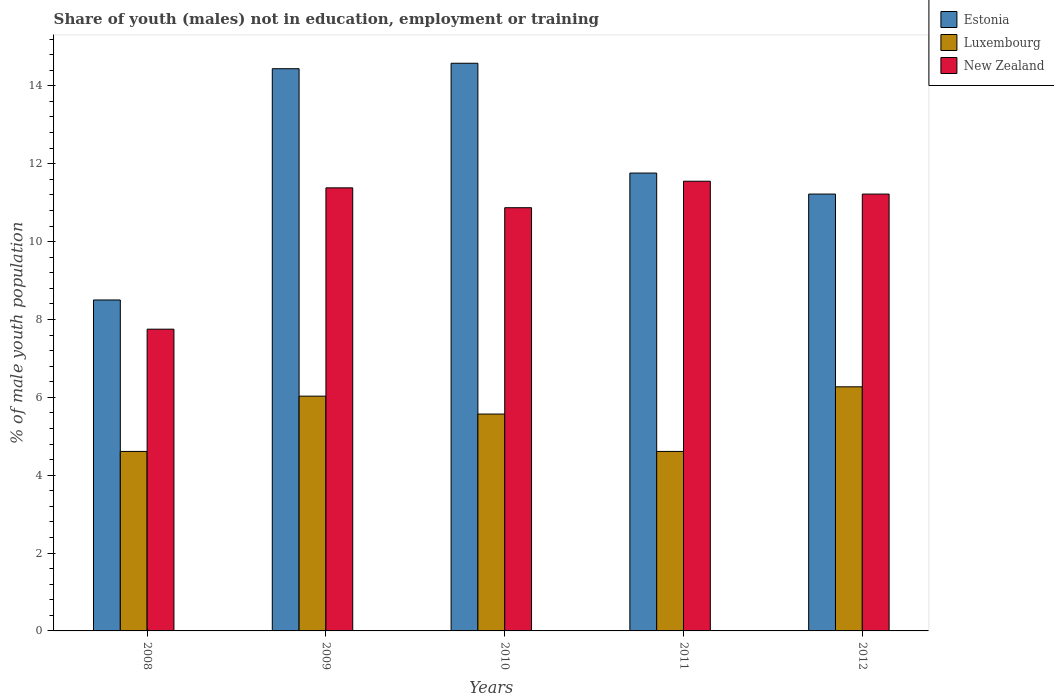How many different coloured bars are there?
Make the answer very short. 3. Are the number of bars on each tick of the X-axis equal?
Keep it short and to the point. Yes. How many bars are there on the 1st tick from the right?
Make the answer very short. 3. What is the label of the 5th group of bars from the left?
Ensure brevity in your answer.  2012. In how many cases, is the number of bars for a given year not equal to the number of legend labels?
Your answer should be very brief. 0. What is the percentage of unemployed males population in in Luxembourg in 2010?
Provide a short and direct response. 5.57. Across all years, what is the maximum percentage of unemployed males population in in New Zealand?
Offer a terse response. 11.55. Across all years, what is the minimum percentage of unemployed males population in in Estonia?
Your answer should be compact. 8.5. In which year was the percentage of unemployed males population in in New Zealand maximum?
Keep it short and to the point. 2011. What is the total percentage of unemployed males population in in New Zealand in the graph?
Your answer should be very brief. 52.77. What is the difference between the percentage of unemployed males population in in New Zealand in 2008 and that in 2012?
Provide a short and direct response. -3.47. What is the difference between the percentage of unemployed males population in in Luxembourg in 2008 and the percentage of unemployed males population in in Estonia in 2012?
Provide a succinct answer. -6.61. What is the average percentage of unemployed males population in in Luxembourg per year?
Make the answer very short. 5.42. In the year 2011, what is the difference between the percentage of unemployed males population in in New Zealand and percentage of unemployed males population in in Luxembourg?
Make the answer very short. 6.94. In how many years, is the percentage of unemployed males population in in Luxembourg greater than 13.2 %?
Your response must be concise. 0. What is the ratio of the percentage of unemployed males population in in Estonia in 2011 to that in 2012?
Provide a short and direct response. 1.05. Is the percentage of unemployed males population in in Estonia in 2011 less than that in 2012?
Your answer should be compact. No. Is the difference between the percentage of unemployed males population in in New Zealand in 2008 and 2011 greater than the difference between the percentage of unemployed males population in in Luxembourg in 2008 and 2011?
Offer a terse response. No. What is the difference between the highest and the second highest percentage of unemployed males population in in Luxembourg?
Offer a very short reply. 0.24. What is the difference between the highest and the lowest percentage of unemployed males population in in Estonia?
Keep it short and to the point. 6.08. What does the 3rd bar from the left in 2012 represents?
Provide a succinct answer. New Zealand. What does the 2nd bar from the right in 2010 represents?
Your answer should be very brief. Luxembourg. Is it the case that in every year, the sum of the percentage of unemployed males population in in Estonia and percentage of unemployed males population in in New Zealand is greater than the percentage of unemployed males population in in Luxembourg?
Offer a terse response. Yes. How many bars are there?
Keep it short and to the point. 15. Are all the bars in the graph horizontal?
Provide a succinct answer. No. How many years are there in the graph?
Your answer should be very brief. 5. What is the difference between two consecutive major ticks on the Y-axis?
Your answer should be compact. 2. Are the values on the major ticks of Y-axis written in scientific E-notation?
Offer a terse response. No. Does the graph contain any zero values?
Ensure brevity in your answer.  No. Where does the legend appear in the graph?
Offer a very short reply. Top right. How many legend labels are there?
Your answer should be very brief. 3. What is the title of the graph?
Keep it short and to the point. Share of youth (males) not in education, employment or training. What is the label or title of the X-axis?
Make the answer very short. Years. What is the label or title of the Y-axis?
Your answer should be compact. % of male youth population. What is the % of male youth population in Estonia in 2008?
Keep it short and to the point. 8.5. What is the % of male youth population of Luxembourg in 2008?
Provide a short and direct response. 4.61. What is the % of male youth population in New Zealand in 2008?
Provide a succinct answer. 7.75. What is the % of male youth population in Estonia in 2009?
Your answer should be very brief. 14.44. What is the % of male youth population in Luxembourg in 2009?
Give a very brief answer. 6.03. What is the % of male youth population of New Zealand in 2009?
Your response must be concise. 11.38. What is the % of male youth population of Estonia in 2010?
Give a very brief answer. 14.58. What is the % of male youth population of Luxembourg in 2010?
Provide a succinct answer. 5.57. What is the % of male youth population of New Zealand in 2010?
Provide a short and direct response. 10.87. What is the % of male youth population in Estonia in 2011?
Keep it short and to the point. 11.76. What is the % of male youth population in Luxembourg in 2011?
Your answer should be compact. 4.61. What is the % of male youth population of New Zealand in 2011?
Your response must be concise. 11.55. What is the % of male youth population of Estonia in 2012?
Provide a short and direct response. 11.22. What is the % of male youth population in Luxembourg in 2012?
Keep it short and to the point. 6.27. What is the % of male youth population of New Zealand in 2012?
Your response must be concise. 11.22. Across all years, what is the maximum % of male youth population of Estonia?
Offer a very short reply. 14.58. Across all years, what is the maximum % of male youth population of Luxembourg?
Provide a short and direct response. 6.27. Across all years, what is the maximum % of male youth population of New Zealand?
Give a very brief answer. 11.55. Across all years, what is the minimum % of male youth population of Estonia?
Offer a terse response. 8.5. Across all years, what is the minimum % of male youth population in Luxembourg?
Provide a short and direct response. 4.61. Across all years, what is the minimum % of male youth population in New Zealand?
Keep it short and to the point. 7.75. What is the total % of male youth population of Estonia in the graph?
Your response must be concise. 60.5. What is the total % of male youth population of Luxembourg in the graph?
Your answer should be compact. 27.09. What is the total % of male youth population of New Zealand in the graph?
Offer a terse response. 52.77. What is the difference between the % of male youth population of Estonia in 2008 and that in 2009?
Your answer should be very brief. -5.94. What is the difference between the % of male youth population of Luxembourg in 2008 and that in 2009?
Give a very brief answer. -1.42. What is the difference between the % of male youth population in New Zealand in 2008 and that in 2009?
Give a very brief answer. -3.63. What is the difference between the % of male youth population in Estonia in 2008 and that in 2010?
Your response must be concise. -6.08. What is the difference between the % of male youth population of Luxembourg in 2008 and that in 2010?
Ensure brevity in your answer.  -0.96. What is the difference between the % of male youth population of New Zealand in 2008 and that in 2010?
Offer a very short reply. -3.12. What is the difference between the % of male youth population of Estonia in 2008 and that in 2011?
Your response must be concise. -3.26. What is the difference between the % of male youth population in Estonia in 2008 and that in 2012?
Give a very brief answer. -2.72. What is the difference between the % of male youth population of Luxembourg in 2008 and that in 2012?
Make the answer very short. -1.66. What is the difference between the % of male youth population of New Zealand in 2008 and that in 2012?
Offer a terse response. -3.47. What is the difference between the % of male youth population in Estonia in 2009 and that in 2010?
Make the answer very short. -0.14. What is the difference between the % of male youth population in Luxembourg in 2009 and that in 2010?
Ensure brevity in your answer.  0.46. What is the difference between the % of male youth population in New Zealand in 2009 and that in 2010?
Ensure brevity in your answer.  0.51. What is the difference between the % of male youth population of Estonia in 2009 and that in 2011?
Offer a terse response. 2.68. What is the difference between the % of male youth population in Luxembourg in 2009 and that in 2011?
Your answer should be very brief. 1.42. What is the difference between the % of male youth population of New Zealand in 2009 and that in 2011?
Keep it short and to the point. -0.17. What is the difference between the % of male youth population of Estonia in 2009 and that in 2012?
Your answer should be compact. 3.22. What is the difference between the % of male youth population of Luxembourg in 2009 and that in 2012?
Your answer should be very brief. -0.24. What is the difference between the % of male youth population of New Zealand in 2009 and that in 2012?
Your response must be concise. 0.16. What is the difference between the % of male youth population of Estonia in 2010 and that in 2011?
Provide a succinct answer. 2.82. What is the difference between the % of male youth population of New Zealand in 2010 and that in 2011?
Your answer should be very brief. -0.68. What is the difference between the % of male youth population of Estonia in 2010 and that in 2012?
Provide a succinct answer. 3.36. What is the difference between the % of male youth population in Luxembourg in 2010 and that in 2012?
Make the answer very short. -0.7. What is the difference between the % of male youth population in New Zealand in 2010 and that in 2012?
Provide a short and direct response. -0.35. What is the difference between the % of male youth population of Estonia in 2011 and that in 2012?
Keep it short and to the point. 0.54. What is the difference between the % of male youth population in Luxembourg in 2011 and that in 2012?
Give a very brief answer. -1.66. What is the difference between the % of male youth population of New Zealand in 2011 and that in 2012?
Provide a succinct answer. 0.33. What is the difference between the % of male youth population of Estonia in 2008 and the % of male youth population of Luxembourg in 2009?
Offer a very short reply. 2.47. What is the difference between the % of male youth population of Estonia in 2008 and the % of male youth population of New Zealand in 2009?
Your answer should be very brief. -2.88. What is the difference between the % of male youth population of Luxembourg in 2008 and the % of male youth population of New Zealand in 2009?
Offer a terse response. -6.77. What is the difference between the % of male youth population of Estonia in 2008 and the % of male youth population of Luxembourg in 2010?
Provide a succinct answer. 2.93. What is the difference between the % of male youth population in Estonia in 2008 and the % of male youth population in New Zealand in 2010?
Ensure brevity in your answer.  -2.37. What is the difference between the % of male youth population of Luxembourg in 2008 and the % of male youth population of New Zealand in 2010?
Provide a succinct answer. -6.26. What is the difference between the % of male youth population in Estonia in 2008 and the % of male youth population in Luxembourg in 2011?
Ensure brevity in your answer.  3.89. What is the difference between the % of male youth population in Estonia in 2008 and the % of male youth population in New Zealand in 2011?
Make the answer very short. -3.05. What is the difference between the % of male youth population in Luxembourg in 2008 and the % of male youth population in New Zealand in 2011?
Offer a terse response. -6.94. What is the difference between the % of male youth population in Estonia in 2008 and the % of male youth population in Luxembourg in 2012?
Provide a succinct answer. 2.23. What is the difference between the % of male youth population of Estonia in 2008 and the % of male youth population of New Zealand in 2012?
Your answer should be compact. -2.72. What is the difference between the % of male youth population in Luxembourg in 2008 and the % of male youth population in New Zealand in 2012?
Your answer should be compact. -6.61. What is the difference between the % of male youth population of Estonia in 2009 and the % of male youth population of Luxembourg in 2010?
Provide a succinct answer. 8.87. What is the difference between the % of male youth population in Estonia in 2009 and the % of male youth population in New Zealand in 2010?
Give a very brief answer. 3.57. What is the difference between the % of male youth population in Luxembourg in 2009 and the % of male youth population in New Zealand in 2010?
Your answer should be very brief. -4.84. What is the difference between the % of male youth population of Estonia in 2009 and the % of male youth population of Luxembourg in 2011?
Your answer should be very brief. 9.83. What is the difference between the % of male youth population of Estonia in 2009 and the % of male youth population of New Zealand in 2011?
Your response must be concise. 2.89. What is the difference between the % of male youth population of Luxembourg in 2009 and the % of male youth population of New Zealand in 2011?
Your response must be concise. -5.52. What is the difference between the % of male youth population of Estonia in 2009 and the % of male youth population of Luxembourg in 2012?
Make the answer very short. 8.17. What is the difference between the % of male youth population in Estonia in 2009 and the % of male youth population in New Zealand in 2012?
Offer a terse response. 3.22. What is the difference between the % of male youth population in Luxembourg in 2009 and the % of male youth population in New Zealand in 2012?
Your answer should be very brief. -5.19. What is the difference between the % of male youth population in Estonia in 2010 and the % of male youth population in Luxembourg in 2011?
Your answer should be very brief. 9.97. What is the difference between the % of male youth population of Estonia in 2010 and the % of male youth population of New Zealand in 2011?
Provide a short and direct response. 3.03. What is the difference between the % of male youth population of Luxembourg in 2010 and the % of male youth population of New Zealand in 2011?
Provide a short and direct response. -5.98. What is the difference between the % of male youth population of Estonia in 2010 and the % of male youth population of Luxembourg in 2012?
Give a very brief answer. 8.31. What is the difference between the % of male youth population in Estonia in 2010 and the % of male youth population in New Zealand in 2012?
Your answer should be compact. 3.36. What is the difference between the % of male youth population of Luxembourg in 2010 and the % of male youth population of New Zealand in 2012?
Provide a succinct answer. -5.65. What is the difference between the % of male youth population of Estonia in 2011 and the % of male youth population of Luxembourg in 2012?
Provide a short and direct response. 5.49. What is the difference between the % of male youth population of Estonia in 2011 and the % of male youth population of New Zealand in 2012?
Ensure brevity in your answer.  0.54. What is the difference between the % of male youth population of Luxembourg in 2011 and the % of male youth population of New Zealand in 2012?
Provide a succinct answer. -6.61. What is the average % of male youth population of Luxembourg per year?
Make the answer very short. 5.42. What is the average % of male youth population of New Zealand per year?
Make the answer very short. 10.55. In the year 2008, what is the difference between the % of male youth population of Estonia and % of male youth population of Luxembourg?
Give a very brief answer. 3.89. In the year 2008, what is the difference between the % of male youth population in Estonia and % of male youth population in New Zealand?
Your response must be concise. 0.75. In the year 2008, what is the difference between the % of male youth population in Luxembourg and % of male youth population in New Zealand?
Offer a very short reply. -3.14. In the year 2009, what is the difference between the % of male youth population in Estonia and % of male youth population in Luxembourg?
Make the answer very short. 8.41. In the year 2009, what is the difference between the % of male youth population of Estonia and % of male youth population of New Zealand?
Offer a terse response. 3.06. In the year 2009, what is the difference between the % of male youth population of Luxembourg and % of male youth population of New Zealand?
Make the answer very short. -5.35. In the year 2010, what is the difference between the % of male youth population in Estonia and % of male youth population in Luxembourg?
Provide a succinct answer. 9.01. In the year 2010, what is the difference between the % of male youth population in Estonia and % of male youth population in New Zealand?
Provide a short and direct response. 3.71. In the year 2010, what is the difference between the % of male youth population of Luxembourg and % of male youth population of New Zealand?
Offer a terse response. -5.3. In the year 2011, what is the difference between the % of male youth population of Estonia and % of male youth population of Luxembourg?
Your answer should be compact. 7.15. In the year 2011, what is the difference between the % of male youth population in Estonia and % of male youth population in New Zealand?
Keep it short and to the point. 0.21. In the year 2011, what is the difference between the % of male youth population in Luxembourg and % of male youth population in New Zealand?
Offer a very short reply. -6.94. In the year 2012, what is the difference between the % of male youth population in Estonia and % of male youth population in Luxembourg?
Give a very brief answer. 4.95. In the year 2012, what is the difference between the % of male youth population of Estonia and % of male youth population of New Zealand?
Give a very brief answer. 0. In the year 2012, what is the difference between the % of male youth population of Luxembourg and % of male youth population of New Zealand?
Provide a short and direct response. -4.95. What is the ratio of the % of male youth population in Estonia in 2008 to that in 2009?
Ensure brevity in your answer.  0.59. What is the ratio of the % of male youth population in Luxembourg in 2008 to that in 2009?
Offer a terse response. 0.76. What is the ratio of the % of male youth population in New Zealand in 2008 to that in 2009?
Provide a succinct answer. 0.68. What is the ratio of the % of male youth population of Estonia in 2008 to that in 2010?
Ensure brevity in your answer.  0.58. What is the ratio of the % of male youth population in Luxembourg in 2008 to that in 2010?
Give a very brief answer. 0.83. What is the ratio of the % of male youth population of New Zealand in 2008 to that in 2010?
Offer a very short reply. 0.71. What is the ratio of the % of male youth population in Estonia in 2008 to that in 2011?
Give a very brief answer. 0.72. What is the ratio of the % of male youth population of New Zealand in 2008 to that in 2011?
Keep it short and to the point. 0.67. What is the ratio of the % of male youth population in Estonia in 2008 to that in 2012?
Make the answer very short. 0.76. What is the ratio of the % of male youth population of Luxembourg in 2008 to that in 2012?
Provide a succinct answer. 0.74. What is the ratio of the % of male youth population of New Zealand in 2008 to that in 2012?
Offer a very short reply. 0.69. What is the ratio of the % of male youth population of Luxembourg in 2009 to that in 2010?
Provide a succinct answer. 1.08. What is the ratio of the % of male youth population of New Zealand in 2009 to that in 2010?
Provide a short and direct response. 1.05. What is the ratio of the % of male youth population of Estonia in 2009 to that in 2011?
Provide a short and direct response. 1.23. What is the ratio of the % of male youth population in Luxembourg in 2009 to that in 2011?
Give a very brief answer. 1.31. What is the ratio of the % of male youth population of Estonia in 2009 to that in 2012?
Make the answer very short. 1.29. What is the ratio of the % of male youth population in Luxembourg in 2009 to that in 2012?
Make the answer very short. 0.96. What is the ratio of the % of male youth population in New Zealand in 2009 to that in 2012?
Keep it short and to the point. 1.01. What is the ratio of the % of male youth population in Estonia in 2010 to that in 2011?
Give a very brief answer. 1.24. What is the ratio of the % of male youth population in Luxembourg in 2010 to that in 2011?
Give a very brief answer. 1.21. What is the ratio of the % of male youth population in New Zealand in 2010 to that in 2011?
Give a very brief answer. 0.94. What is the ratio of the % of male youth population of Estonia in 2010 to that in 2012?
Give a very brief answer. 1.3. What is the ratio of the % of male youth population of Luxembourg in 2010 to that in 2012?
Ensure brevity in your answer.  0.89. What is the ratio of the % of male youth population of New Zealand in 2010 to that in 2012?
Offer a very short reply. 0.97. What is the ratio of the % of male youth population of Estonia in 2011 to that in 2012?
Provide a succinct answer. 1.05. What is the ratio of the % of male youth population of Luxembourg in 2011 to that in 2012?
Keep it short and to the point. 0.74. What is the ratio of the % of male youth population in New Zealand in 2011 to that in 2012?
Offer a terse response. 1.03. What is the difference between the highest and the second highest % of male youth population of Estonia?
Your answer should be compact. 0.14. What is the difference between the highest and the second highest % of male youth population in Luxembourg?
Ensure brevity in your answer.  0.24. What is the difference between the highest and the second highest % of male youth population of New Zealand?
Offer a terse response. 0.17. What is the difference between the highest and the lowest % of male youth population of Estonia?
Ensure brevity in your answer.  6.08. What is the difference between the highest and the lowest % of male youth population in Luxembourg?
Your answer should be compact. 1.66. 